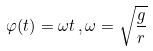Convert formula to latex. <formula><loc_0><loc_0><loc_500><loc_500>\varphi ( t ) = \omega t \, , \omega = { \sqrt { \frac { g } { r } } }</formula> 